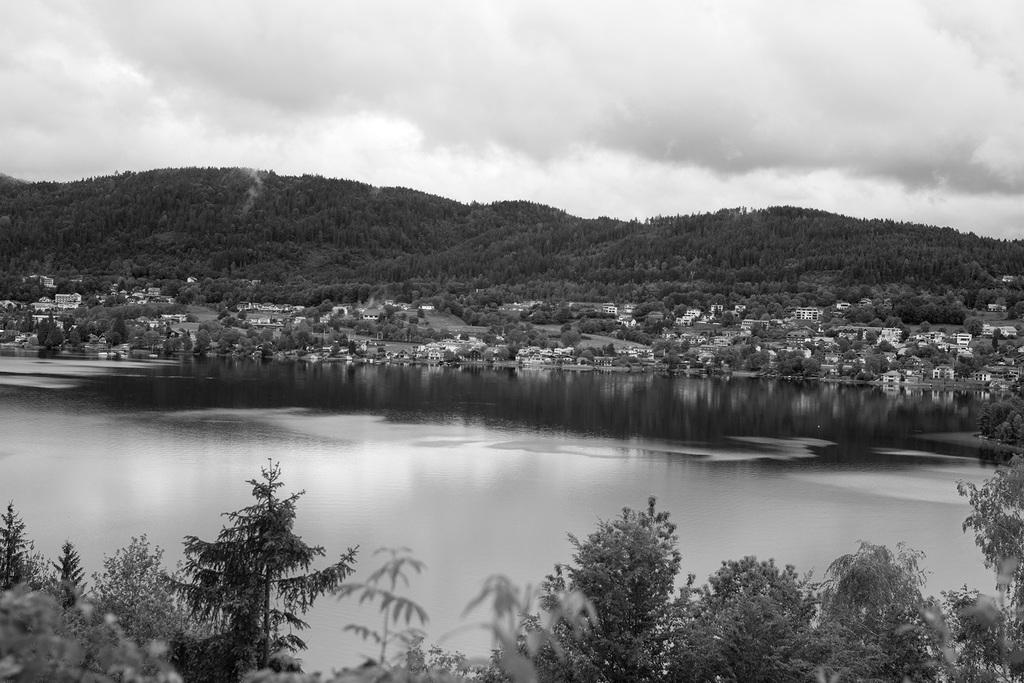What type of natural elements can be seen in the image? There are trees and water visible in the image. What type of man-made structures are present in the image? There are buildings in the image. What type of terrain is visible in the image? There are hills in the image. What is visible in the background of the image? There are clouds in the background of the image. What is the color scheme of the image? The photography is in black and white. Where is the playground located in the image? There is no playground present in the image. What type of dinosaurs can be seen roaming in the image? There are no dinosaurs present in the image. 